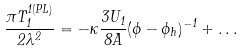Convert formula to latex. <formula><loc_0><loc_0><loc_500><loc_500>\frac { \pi T _ { 1 } ^ { 1 ( P L ) } } { 2 \lambda ^ { 2 } } = - \kappa \frac { 3 U _ { 1 } } { 8 A } ( \phi - \phi _ { h } ) ^ { - 1 } + \dots</formula> 